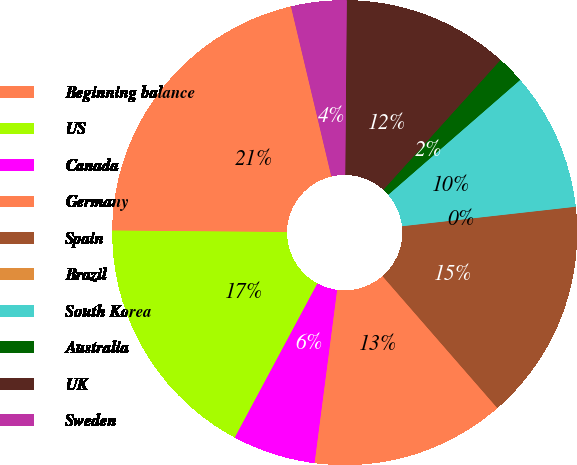Convert chart to OTSL. <chart><loc_0><loc_0><loc_500><loc_500><pie_chart><fcel>Beginning balance<fcel>US<fcel>Canada<fcel>Germany<fcel>Spain<fcel>Brazil<fcel>South Korea<fcel>Australia<fcel>UK<fcel>Sweden<nl><fcel>21.15%<fcel>17.31%<fcel>5.77%<fcel>13.46%<fcel>15.38%<fcel>0.0%<fcel>9.62%<fcel>1.92%<fcel>11.54%<fcel>3.85%<nl></chart> 